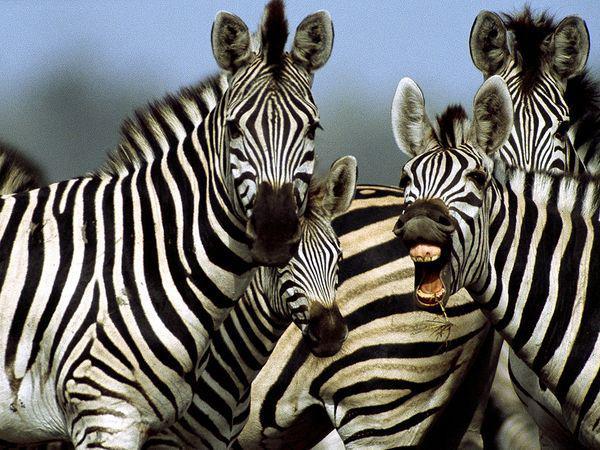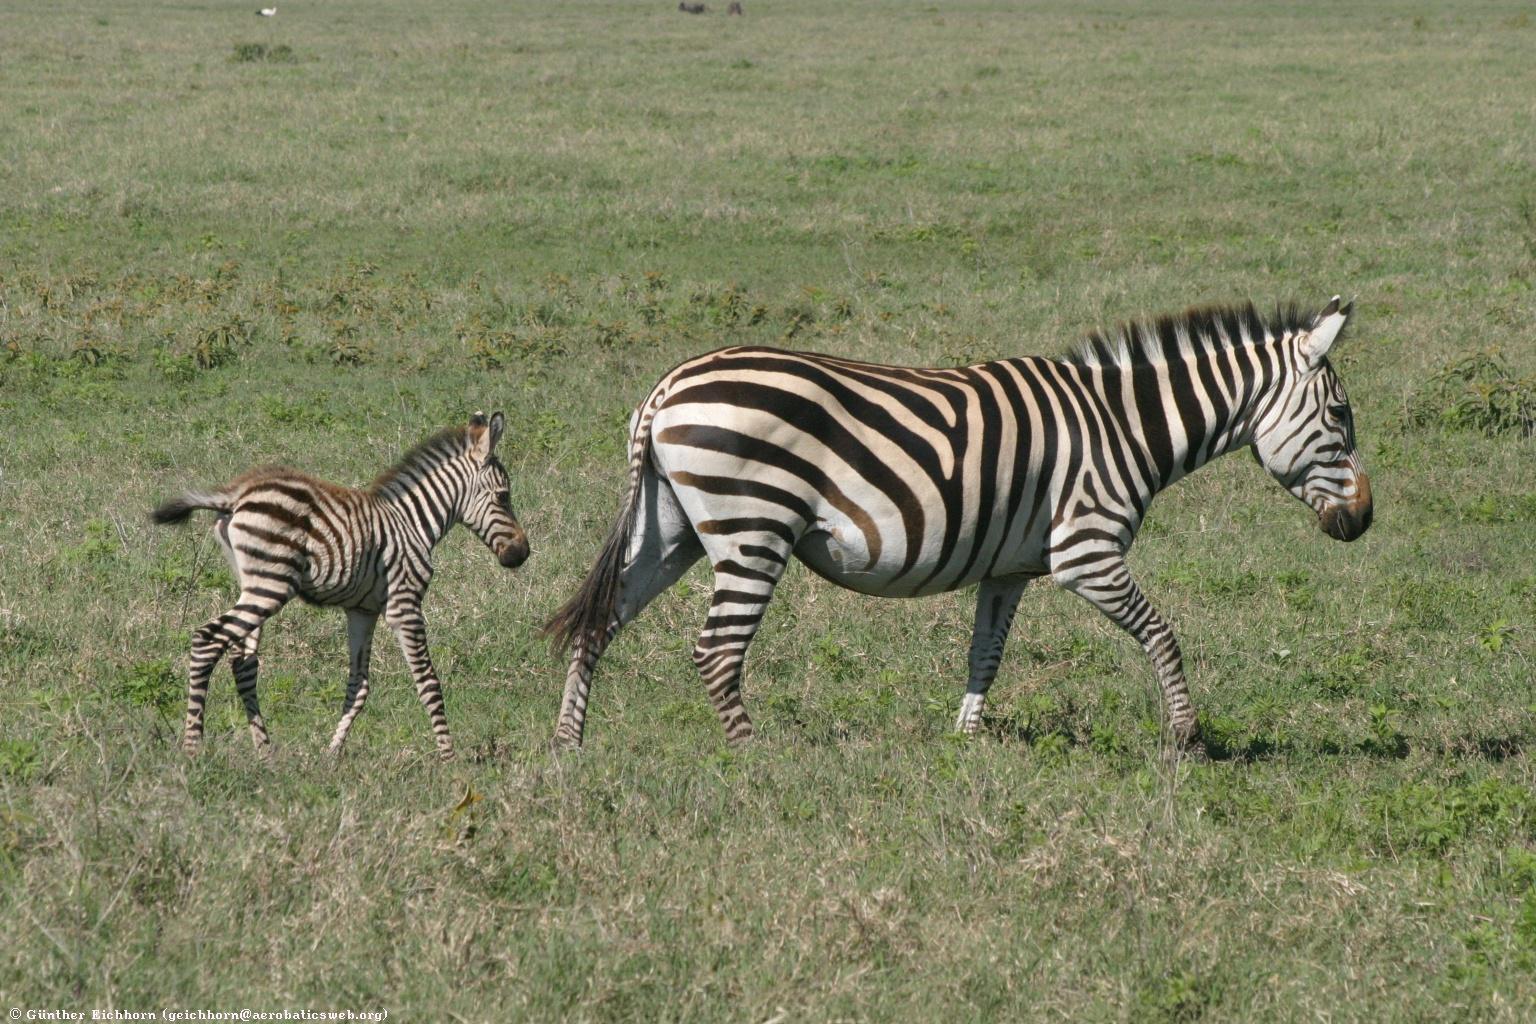The first image is the image on the left, the second image is the image on the right. For the images shown, is this caption "No image contains fewer that three zebras, and the left image includes rear-turned zebras in the foreground." true? Answer yes or no. No. The first image is the image on the left, the second image is the image on the right. Examine the images to the left and right. Is the description "The image on the right has two or fewer zebras." accurate? Answer yes or no. Yes. 